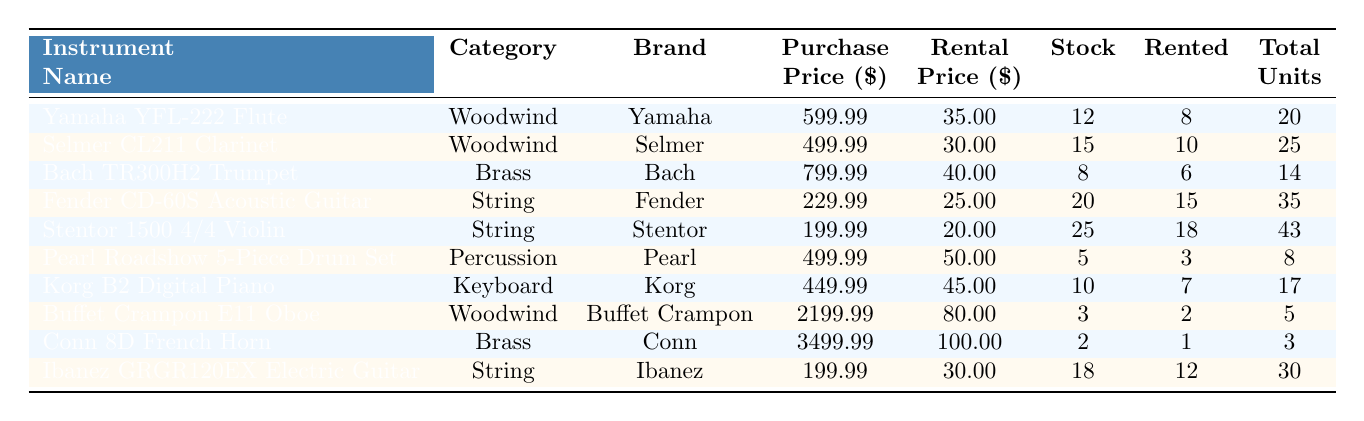What is the rental price of the Yamaha YFL-222 Flute? The table clearly indicates that the rental price for the Yamaha YFL-222 Flute is listed in the rental price column. That value is 35.00.
Answer: 35.00 How many Conn 8D French Horn instruments are currently rented out? Referring to the table, the quantity rented for the Conn 8D French Horn is found in the 'Quantity Rented' column, which shows a value of 1.
Answer: 1 What is the total quantity of Stentor 1500 4/4 Violins in stock? The total quantity in stock for the Stentor 1500 4/4 Violin is given in the 'Quantity In Stock' column, which is 25.
Answer: 25 Which instrument has the highest purchase price, and what is that price? Looking at the 'Purchase Price' column, the highest value is P3,499.99 for the Conn 8D French Horn. Therefore, it has the highest purchase price.
Answer: Conn 8D French Horn, 3499.99 What is the average rental price of all instruments listed in the table? To find the average rental price, we sum up all the rental prices (35 + 30 + 40 + 25 + 20 + 50 + 45 + 80 + 100 + 30 = 450) and divide by the number of instruments (10), resulting in an average rental price of 450/10 = 45.00.
Answer: 45.00 How many more Fender CD-60S Acoustic Guitars are rented compared to the Pearl Roadshow Drum Set? The Fender CD-60S has 15 rented out, and the Pearl Roadshow has 3 rented. The difference is 15 - 3 = 12.
Answer: 12 Is the total quantity of Korg B2 Digital Pianos in stock greater than the total quantity of Buffet Crampon E11 Oboes? The Korg B2 Digital Piano has 10 in stock while the Buffet Crampon E11 Oboe has 3. Since 10 is greater than 3, the statement is true.
Answer: Yes What is the total rental income from the quantity of Stentor 1500 4/4 Violins currently rented out? To calculate the rental income, we multiply the rental price (20.00) by the quantity rented (18), giving us 20.00 * 18 = 360.00.
Answer: 360.00 Which category has the most instruments currently rented? By looking at the 'Quantity Rented' column, we see that the String category has 15 (Fender CD-60S) + 18 (Stentor 1500) + 12 (Ibanez GRGR120EX) = 45, the Woodwind has 8 + 10 + 2 = 20, the Brass has 6 + 1 = 7, the Percussion has 3, and the Keyboard has 7. Therefore, the String category has the most.
Answer: String What is the maximum rental price among the instruments, and which instrument is it associated with? The maximum rental price noted in the table is $100.00, associated with the Conn 8D French Horn.
Answer: Conn 8D French Horn, 100.00 